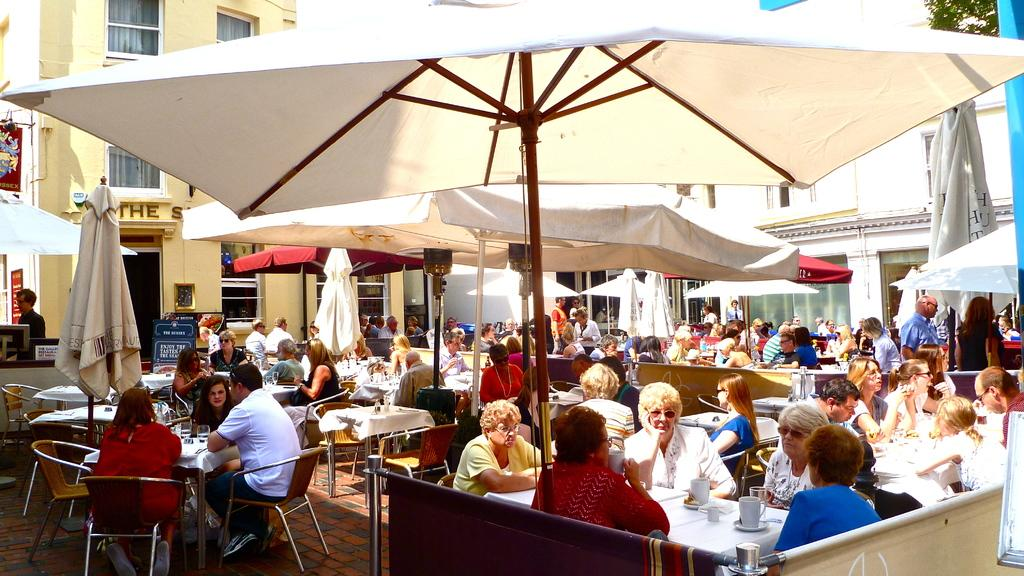How many people are in the image? There is a group of people in the image. What are some of the people in the image doing? Some people are sitting on chairs, while others are standing. What can be seen in the background of the image? There is a building visible in the background of the image, and there are windows in the background as well. How many properties does the crow own in the image? There is no crow present in the image, and therefore no information about its properties can be provided. 